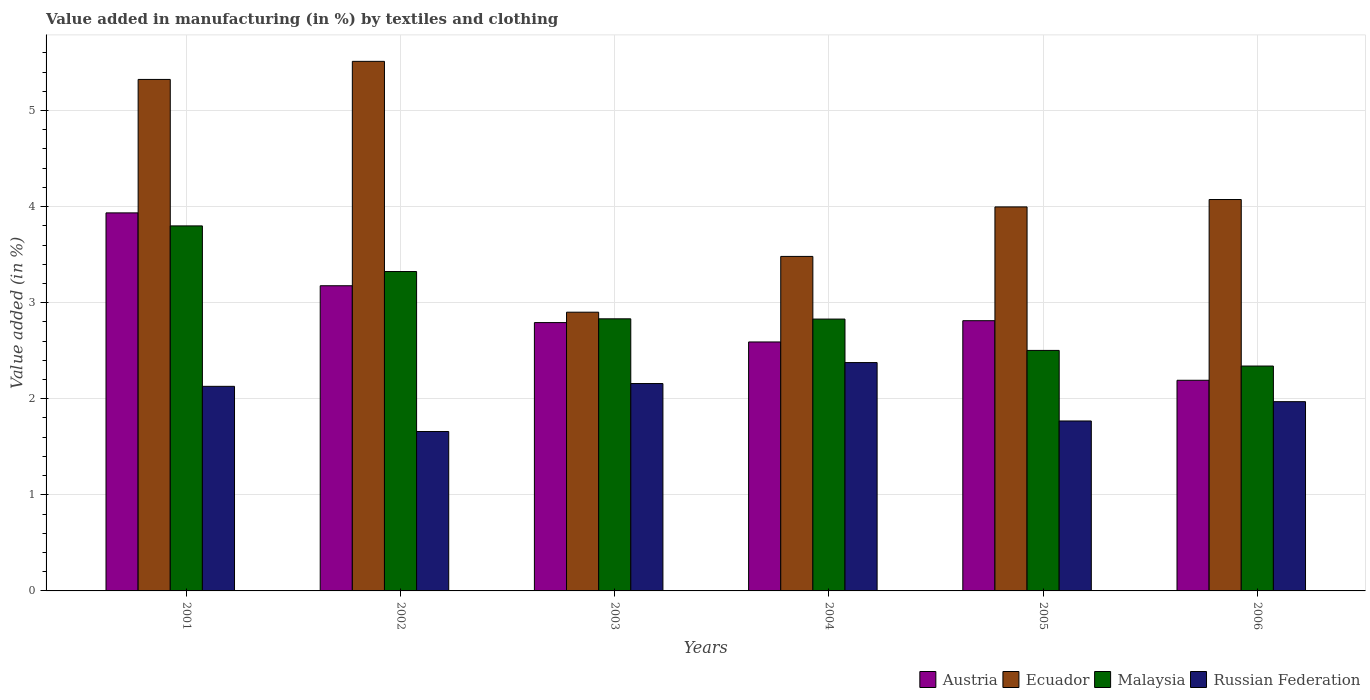How many groups of bars are there?
Make the answer very short. 6. Are the number of bars on each tick of the X-axis equal?
Give a very brief answer. Yes. What is the label of the 5th group of bars from the left?
Provide a short and direct response. 2005. What is the percentage of value added in manufacturing by textiles and clothing in Ecuador in 2004?
Give a very brief answer. 3.48. Across all years, what is the maximum percentage of value added in manufacturing by textiles and clothing in Ecuador?
Offer a very short reply. 5.51. Across all years, what is the minimum percentage of value added in manufacturing by textiles and clothing in Austria?
Provide a succinct answer. 2.19. In which year was the percentage of value added in manufacturing by textiles and clothing in Ecuador maximum?
Provide a short and direct response. 2002. In which year was the percentage of value added in manufacturing by textiles and clothing in Ecuador minimum?
Your answer should be compact. 2003. What is the total percentage of value added in manufacturing by textiles and clothing in Russian Federation in the graph?
Offer a very short reply. 12.06. What is the difference between the percentage of value added in manufacturing by textiles and clothing in Russian Federation in 2001 and that in 2006?
Your answer should be compact. 0.16. What is the difference between the percentage of value added in manufacturing by textiles and clothing in Austria in 2001 and the percentage of value added in manufacturing by textiles and clothing in Russian Federation in 2002?
Ensure brevity in your answer.  2.28. What is the average percentage of value added in manufacturing by textiles and clothing in Russian Federation per year?
Your answer should be very brief. 2.01. In the year 2005, what is the difference between the percentage of value added in manufacturing by textiles and clothing in Malaysia and percentage of value added in manufacturing by textiles and clothing in Ecuador?
Offer a very short reply. -1.49. In how many years, is the percentage of value added in manufacturing by textiles and clothing in Malaysia greater than 4 %?
Give a very brief answer. 0. What is the ratio of the percentage of value added in manufacturing by textiles and clothing in Ecuador in 2002 to that in 2004?
Offer a very short reply. 1.58. Is the percentage of value added in manufacturing by textiles and clothing in Russian Federation in 2003 less than that in 2004?
Give a very brief answer. Yes. Is the difference between the percentage of value added in manufacturing by textiles and clothing in Malaysia in 2002 and 2003 greater than the difference between the percentage of value added in manufacturing by textiles and clothing in Ecuador in 2002 and 2003?
Make the answer very short. No. What is the difference between the highest and the second highest percentage of value added in manufacturing by textiles and clothing in Russian Federation?
Offer a terse response. 0.22. What is the difference between the highest and the lowest percentage of value added in manufacturing by textiles and clothing in Ecuador?
Offer a terse response. 2.61. Is the sum of the percentage of value added in manufacturing by textiles and clothing in Russian Federation in 2001 and 2006 greater than the maximum percentage of value added in manufacturing by textiles and clothing in Austria across all years?
Give a very brief answer. Yes. What does the 4th bar from the left in 2003 represents?
Ensure brevity in your answer.  Russian Federation. What does the 2nd bar from the right in 2002 represents?
Give a very brief answer. Malaysia. Are all the bars in the graph horizontal?
Ensure brevity in your answer.  No. What is the difference between two consecutive major ticks on the Y-axis?
Make the answer very short. 1. Does the graph contain any zero values?
Provide a succinct answer. No. Where does the legend appear in the graph?
Make the answer very short. Bottom right. How many legend labels are there?
Offer a very short reply. 4. How are the legend labels stacked?
Your answer should be very brief. Horizontal. What is the title of the graph?
Your answer should be very brief. Value added in manufacturing (in %) by textiles and clothing. Does "American Samoa" appear as one of the legend labels in the graph?
Keep it short and to the point. No. What is the label or title of the Y-axis?
Your answer should be very brief. Value added (in %). What is the Value added (in %) of Austria in 2001?
Offer a very short reply. 3.93. What is the Value added (in %) of Ecuador in 2001?
Your answer should be compact. 5.32. What is the Value added (in %) of Malaysia in 2001?
Give a very brief answer. 3.8. What is the Value added (in %) of Russian Federation in 2001?
Your response must be concise. 2.13. What is the Value added (in %) in Austria in 2002?
Keep it short and to the point. 3.18. What is the Value added (in %) of Ecuador in 2002?
Ensure brevity in your answer.  5.51. What is the Value added (in %) in Malaysia in 2002?
Your answer should be very brief. 3.32. What is the Value added (in %) in Russian Federation in 2002?
Keep it short and to the point. 1.66. What is the Value added (in %) of Austria in 2003?
Your answer should be very brief. 2.79. What is the Value added (in %) of Ecuador in 2003?
Your response must be concise. 2.9. What is the Value added (in %) of Malaysia in 2003?
Provide a succinct answer. 2.83. What is the Value added (in %) of Russian Federation in 2003?
Your response must be concise. 2.16. What is the Value added (in %) in Austria in 2004?
Provide a succinct answer. 2.59. What is the Value added (in %) of Ecuador in 2004?
Offer a very short reply. 3.48. What is the Value added (in %) in Malaysia in 2004?
Give a very brief answer. 2.83. What is the Value added (in %) in Russian Federation in 2004?
Your response must be concise. 2.38. What is the Value added (in %) in Austria in 2005?
Offer a terse response. 2.81. What is the Value added (in %) in Ecuador in 2005?
Offer a terse response. 4. What is the Value added (in %) of Malaysia in 2005?
Your response must be concise. 2.5. What is the Value added (in %) in Russian Federation in 2005?
Your response must be concise. 1.77. What is the Value added (in %) of Austria in 2006?
Ensure brevity in your answer.  2.19. What is the Value added (in %) of Ecuador in 2006?
Your answer should be very brief. 4.07. What is the Value added (in %) of Malaysia in 2006?
Make the answer very short. 2.34. What is the Value added (in %) of Russian Federation in 2006?
Your answer should be very brief. 1.97. Across all years, what is the maximum Value added (in %) of Austria?
Provide a short and direct response. 3.93. Across all years, what is the maximum Value added (in %) of Ecuador?
Offer a terse response. 5.51. Across all years, what is the maximum Value added (in %) in Malaysia?
Your answer should be very brief. 3.8. Across all years, what is the maximum Value added (in %) in Russian Federation?
Your answer should be very brief. 2.38. Across all years, what is the minimum Value added (in %) in Austria?
Provide a succinct answer. 2.19. Across all years, what is the minimum Value added (in %) of Ecuador?
Your answer should be very brief. 2.9. Across all years, what is the minimum Value added (in %) of Malaysia?
Your answer should be compact. 2.34. Across all years, what is the minimum Value added (in %) in Russian Federation?
Provide a short and direct response. 1.66. What is the total Value added (in %) in Austria in the graph?
Ensure brevity in your answer.  17.5. What is the total Value added (in %) in Ecuador in the graph?
Ensure brevity in your answer.  25.29. What is the total Value added (in %) of Malaysia in the graph?
Your response must be concise. 17.63. What is the total Value added (in %) of Russian Federation in the graph?
Provide a short and direct response. 12.06. What is the difference between the Value added (in %) in Austria in 2001 and that in 2002?
Your response must be concise. 0.76. What is the difference between the Value added (in %) of Ecuador in 2001 and that in 2002?
Provide a short and direct response. -0.19. What is the difference between the Value added (in %) in Malaysia in 2001 and that in 2002?
Provide a short and direct response. 0.47. What is the difference between the Value added (in %) in Russian Federation in 2001 and that in 2002?
Give a very brief answer. 0.47. What is the difference between the Value added (in %) of Austria in 2001 and that in 2003?
Offer a terse response. 1.14. What is the difference between the Value added (in %) in Ecuador in 2001 and that in 2003?
Your answer should be compact. 2.42. What is the difference between the Value added (in %) in Malaysia in 2001 and that in 2003?
Make the answer very short. 0.97. What is the difference between the Value added (in %) of Russian Federation in 2001 and that in 2003?
Provide a short and direct response. -0.03. What is the difference between the Value added (in %) of Austria in 2001 and that in 2004?
Your answer should be very brief. 1.34. What is the difference between the Value added (in %) in Ecuador in 2001 and that in 2004?
Keep it short and to the point. 1.84. What is the difference between the Value added (in %) in Malaysia in 2001 and that in 2004?
Keep it short and to the point. 0.97. What is the difference between the Value added (in %) in Russian Federation in 2001 and that in 2004?
Offer a terse response. -0.25. What is the difference between the Value added (in %) in Austria in 2001 and that in 2005?
Ensure brevity in your answer.  1.12. What is the difference between the Value added (in %) of Ecuador in 2001 and that in 2005?
Provide a short and direct response. 1.33. What is the difference between the Value added (in %) in Malaysia in 2001 and that in 2005?
Your answer should be compact. 1.3. What is the difference between the Value added (in %) of Russian Federation in 2001 and that in 2005?
Give a very brief answer. 0.36. What is the difference between the Value added (in %) of Austria in 2001 and that in 2006?
Your answer should be very brief. 1.74. What is the difference between the Value added (in %) of Ecuador in 2001 and that in 2006?
Offer a terse response. 1.25. What is the difference between the Value added (in %) of Malaysia in 2001 and that in 2006?
Ensure brevity in your answer.  1.46. What is the difference between the Value added (in %) in Russian Federation in 2001 and that in 2006?
Make the answer very short. 0.16. What is the difference between the Value added (in %) of Austria in 2002 and that in 2003?
Make the answer very short. 0.38. What is the difference between the Value added (in %) of Ecuador in 2002 and that in 2003?
Provide a short and direct response. 2.61. What is the difference between the Value added (in %) of Malaysia in 2002 and that in 2003?
Your response must be concise. 0.49. What is the difference between the Value added (in %) of Russian Federation in 2002 and that in 2003?
Your answer should be very brief. -0.5. What is the difference between the Value added (in %) of Austria in 2002 and that in 2004?
Offer a very short reply. 0.59. What is the difference between the Value added (in %) of Ecuador in 2002 and that in 2004?
Make the answer very short. 2.03. What is the difference between the Value added (in %) in Malaysia in 2002 and that in 2004?
Give a very brief answer. 0.49. What is the difference between the Value added (in %) in Russian Federation in 2002 and that in 2004?
Keep it short and to the point. -0.72. What is the difference between the Value added (in %) in Austria in 2002 and that in 2005?
Ensure brevity in your answer.  0.36. What is the difference between the Value added (in %) of Ecuador in 2002 and that in 2005?
Your answer should be compact. 1.51. What is the difference between the Value added (in %) in Malaysia in 2002 and that in 2005?
Make the answer very short. 0.82. What is the difference between the Value added (in %) in Russian Federation in 2002 and that in 2005?
Your answer should be compact. -0.11. What is the difference between the Value added (in %) in Austria in 2002 and that in 2006?
Offer a very short reply. 0.98. What is the difference between the Value added (in %) in Ecuador in 2002 and that in 2006?
Your answer should be very brief. 1.44. What is the difference between the Value added (in %) of Malaysia in 2002 and that in 2006?
Ensure brevity in your answer.  0.98. What is the difference between the Value added (in %) of Russian Federation in 2002 and that in 2006?
Offer a terse response. -0.31. What is the difference between the Value added (in %) of Austria in 2003 and that in 2004?
Offer a terse response. 0.2. What is the difference between the Value added (in %) in Ecuador in 2003 and that in 2004?
Your response must be concise. -0.58. What is the difference between the Value added (in %) in Malaysia in 2003 and that in 2004?
Offer a terse response. 0. What is the difference between the Value added (in %) in Russian Federation in 2003 and that in 2004?
Your response must be concise. -0.22. What is the difference between the Value added (in %) in Austria in 2003 and that in 2005?
Give a very brief answer. -0.02. What is the difference between the Value added (in %) in Ecuador in 2003 and that in 2005?
Your response must be concise. -1.1. What is the difference between the Value added (in %) in Malaysia in 2003 and that in 2005?
Your answer should be compact. 0.33. What is the difference between the Value added (in %) in Russian Federation in 2003 and that in 2005?
Your answer should be very brief. 0.39. What is the difference between the Value added (in %) of Austria in 2003 and that in 2006?
Offer a very short reply. 0.6. What is the difference between the Value added (in %) in Ecuador in 2003 and that in 2006?
Ensure brevity in your answer.  -1.17. What is the difference between the Value added (in %) in Malaysia in 2003 and that in 2006?
Provide a succinct answer. 0.49. What is the difference between the Value added (in %) in Russian Federation in 2003 and that in 2006?
Provide a short and direct response. 0.19. What is the difference between the Value added (in %) in Austria in 2004 and that in 2005?
Make the answer very short. -0.22. What is the difference between the Value added (in %) of Ecuador in 2004 and that in 2005?
Your answer should be compact. -0.52. What is the difference between the Value added (in %) of Malaysia in 2004 and that in 2005?
Your answer should be very brief. 0.33. What is the difference between the Value added (in %) of Russian Federation in 2004 and that in 2005?
Give a very brief answer. 0.61. What is the difference between the Value added (in %) in Austria in 2004 and that in 2006?
Make the answer very short. 0.4. What is the difference between the Value added (in %) of Ecuador in 2004 and that in 2006?
Offer a terse response. -0.59. What is the difference between the Value added (in %) in Malaysia in 2004 and that in 2006?
Keep it short and to the point. 0.49. What is the difference between the Value added (in %) of Russian Federation in 2004 and that in 2006?
Your response must be concise. 0.41. What is the difference between the Value added (in %) of Austria in 2005 and that in 2006?
Offer a terse response. 0.62. What is the difference between the Value added (in %) in Ecuador in 2005 and that in 2006?
Offer a very short reply. -0.08. What is the difference between the Value added (in %) of Malaysia in 2005 and that in 2006?
Keep it short and to the point. 0.16. What is the difference between the Value added (in %) in Russian Federation in 2005 and that in 2006?
Make the answer very short. -0.2. What is the difference between the Value added (in %) of Austria in 2001 and the Value added (in %) of Ecuador in 2002?
Provide a short and direct response. -1.58. What is the difference between the Value added (in %) of Austria in 2001 and the Value added (in %) of Malaysia in 2002?
Provide a succinct answer. 0.61. What is the difference between the Value added (in %) in Austria in 2001 and the Value added (in %) in Russian Federation in 2002?
Your response must be concise. 2.28. What is the difference between the Value added (in %) of Ecuador in 2001 and the Value added (in %) of Malaysia in 2002?
Provide a succinct answer. 2. What is the difference between the Value added (in %) in Ecuador in 2001 and the Value added (in %) in Russian Federation in 2002?
Provide a succinct answer. 3.66. What is the difference between the Value added (in %) of Malaysia in 2001 and the Value added (in %) of Russian Federation in 2002?
Offer a very short reply. 2.14. What is the difference between the Value added (in %) in Austria in 2001 and the Value added (in %) in Ecuador in 2003?
Provide a short and direct response. 1.03. What is the difference between the Value added (in %) of Austria in 2001 and the Value added (in %) of Malaysia in 2003?
Provide a succinct answer. 1.1. What is the difference between the Value added (in %) of Austria in 2001 and the Value added (in %) of Russian Federation in 2003?
Your answer should be very brief. 1.78. What is the difference between the Value added (in %) in Ecuador in 2001 and the Value added (in %) in Malaysia in 2003?
Your answer should be very brief. 2.49. What is the difference between the Value added (in %) of Ecuador in 2001 and the Value added (in %) of Russian Federation in 2003?
Make the answer very short. 3.17. What is the difference between the Value added (in %) of Malaysia in 2001 and the Value added (in %) of Russian Federation in 2003?
Keep it short and to the point. 1.64. What is the difference between the Value added (in %) of Austria in 2001 and the Value added (in %) of Ecuador in 2004?
Make the answer very short. 0.45. What is the difference between the Value added (in %) in Austria in 2001 and the Value added (in %) in Malaysia in 2004?
Give a very brief answer. 1.11. What is the difference between the Value added (in %) of Austria in 2001 and the Value added (in %) of Russian Federation in 2004?
Give a very brief answer. 1.56. What is the difference between the Value added (in %) in Ecuador in 2001 and the Value added (in %) in Malaysia in 2004?
Offer a very short reply. 2.49. What is the difference between the Value added (in %) of Ecuador in 2001 and the Value added (in %) of Russian Federation in 2004?
Offer a very short reply. 2.95. What is the difference between the Value added (in %) of Malaysia in 2001 and the Value added (in %) of Russian Federation in 2004?
Give a very brief answer. 1.42. What is the difference between the Value added (in %) in Austria in 2001 and the Value added (in %) in Ecuador in 2005?
Provide a succinct answer. -0.06. What is the difference between the Value added (in %) in Austria in 2001 and the Value added (in %) in Malaysia in 2005?
Your response must be concise. 1.43. What is the difference between the Value added (in %) in Austria in 2001 and the Value added (in %) in Russian Federation in 2005?
Give a very brief answer. 2.17. What is the difference between the Value added (in %) in Ecuador in 2001 and the Value added (in %) in Malaysia in 2005?
Offer a terse response. 2.82. What is the difference between the Value added (in %) of Ecuador in 2001 and the Value added (in %) of Russian Federation in 2005?
Offer a terse response. 3.55. What is the difference between the Value added (in %) of Malaysia in 2001 and the Value added (in %) of Russian Federation in 2005?
Make the answer very short. 2.03. What is the difference between the Value added (in %) of Austria in 2001 and the Value added (in %) of Ecuador in 2006?
Keep it short and to the point. -0.14. What is the difference between the Value added (in %) of Austria in 2001 and the Value added (in %) of Malaysia in 2006?
Offer a terse response. 1.59. What is the difference between the Value added (in %) in Austria in 2001 and the Value added (in %) in Russian Federation in 2006?
Offer a very short reply. 1.96. What is the difference between the Value added (in %) in Ecuador in 2001 and the Value added (in %) in Malaysia in 2006?
Provide a short and direct response. 2.98. What is the difference between the Value added (in %) of Ecuador in 2001 and the Value added (in %) of Russian Federation in 2006?
Your answer should be compact. 3.35. What is the difference between the Value added (in %) in Malaysia in 2001 and the Value added (in %) in Russian Federation in 2006?
Give a very brief answer. 1.83. What is the difference between the Value added (in %) in Austria in 2002 and the Value added (in %) in Ecuador in 2003?
Keep it short and to the point. 0.28. What is the difference between the Value added (in %) in Austria in 2002 and the Value added (in %) in Malaysia in 2003?
Make the answer very short. 0.34. What is the difference between the Value added (in %) in Austria in 2002 and the Value added (in %) in Russian Federation in 2003?
Your answer should be compact. 1.02. What is the difference between the Value added (in %) of Ecuador in 2002 and the Value added (in %) of Malaysia in 2003?
Offer a very short reply. 2.68. What is the difference between the Value added (in %) of Ecuador in 2002 and the Value added (in %) of Russian Federation in 2003?
Give a very brief answer. 3.35. What is the difference between the Value added (in %) of Malaysia in 2002 and the Value added (in %) of Russian Federation in 2003?
Your answer should be very brief. 1.17. What is the difference between the Value added (in %) in Austria in 2002 and the Value added (in %) in Ecuador in 2004?
Offer a terse response. -0.31. What is the difference between the Value added (in %) in Austria in 2002 and the Value added (in %) in Malaysia in 2004?
Make the answer very short. 0.35. What is the difference between the Value added (in %) in Austria in 2002 and the Value added (in %) in Russian Federation in 2004?
Provide a succinct answer. 0.8. What is the difference between the Value added (in %) of Ecuador in 2002 and the Value added (in %) of Malaysia in 2004?
Ensure brevity in your answer.  2.68. What is the difference between the Value added (in %) in Ecuador in 2002 and the Value added (in %) in Russian Federation in 2004?
Make the answer very short. 3.13. What is the difference between the Value added (in %) in Malaysia in 2002 and the Value added (in %) in Russian Federation in 2004?
Your response must be concise. 0.95. What is the difference between the Value added (in %) of Austria in 2002 and the Value added (in %) of Ecuador in 2005?
Offer a very short reply. -0.82. What is the difference between the Value added (in %) in Austria in 2002 and the Value added (in %) in Malaysia in 2005?
Your response must be concise. 0.67. What is the difference between the Value added (in %) of Austria in 2002 and the Value added (in %) of Russian Federation in 2005?
Offer a very short reply. 1.41. What is the difference between the Value added (in %) in Ecuador in 2002 and the Value added (in %) in Malaysia in 2005?
Provide a short and direct response. 3.01. What is the difference between the Value added (in %) of Ecuador in 2002 and the Value added (in %) of Russian Federation in 2005?
Make the answer very short. 3.74. What is the difference between the Value added (in %) in Malaysia in 2002 and the Value added (in %) in Russian Federation in 2005?
Give a very brief answer. 1.56. What is the difference between the Value added (in %) of Austria in 2002 and the Value added (in %) of Ecuador in 2006?
Your response must be concise. -0.9. What is the difference between the Value added (in %) in Austria in 2002 and the Value added (in %) in Malaysia in 2006?
Your answer should be very brief. 0.84. What is the difference between the Value added (in %) of Austria in 2002 and the Value added (in %) of Russian Federation in 2006?
Make the answer very short. 1.21. What is the difference between the Value added (in %) in Ecuador in 2002 and the Value added (in %) in Malaysia in 2006?
Provide a succinct answer. 3.17. What is the difference between the Value added (in %) of Ecuador in 2002 and the Value added (in %) of Russian Federation in 2006?
Make the answer very short. 3.54. What is the difference between the Value added (in %) of Malaysia in 2002 and the Value added (in %) of Russian Federation in 2006?
Ensure brevity in your answer.  1.35. What is the difference between the Value added (in %) in Austria in 2003 and the Value added (in %) in Ecuador in 2004?
Provide a short and direct response. -0.69. What is the difference between the Value added (in %) of Austria in 2003 and the Value added (in %) of Malaysia in 2004?
Offer a very short reply. -0.04. What is the difference between the Value added (in %) in Austria in 2003 and the Value added (in %) in Russian Federation in 2004?
Provide a short and direct response. 0.42. What is the difference between the Value added (in %) in Ecuador in 2003 and the Value added (in %) in Malaysia in 2004?
Provide a succinct answer. 0.07. What is the difference between the Value added (in %) in Ecuador in 2003 and the Value added (in %) in Russian Federation in 2004?
Provide a succinct answer. 0.52. What is the difference between the Value added (in %) of Malaysia in 2003 and the Value added (in %) of Russian Federation in 2004?
Your answer should be compact. 0.46. What is the difference between the Value added (in %) of Austria in 2003 and the Value added (in %) of Ecuador in 2005?
Ensure brevity in your answer.  -1.2. What is the difference between the Value added (in %) of Austria in 2003 and the Value added (in %) of Malaysia in 2005?
Keep it short and to the point. 0.29. What is the difference between the Value added (in %) of Austria in 2003 and the Value added (in %) of Russian Federation in 2005?
Provide a succinct answer. 1.02. What is the difference between the Value added (in %) of Ecuador in 2003 and the Value added (in %) of Malaysia in 2005?
Provide a succinct answer. 0.4. What is the difference between the Value added (in %) in Ecuador in 2003 and the Value added (in %) in Russian Federation in 2005?
Your answer should be compact. 1.13. What is the difference between the Value added (in %) in Malaysia in 2003 and the Value added (in %) in Russian Federation in 2005?
Your answer should be compact. 1.06. What is the difference between the Value added (in %) of Austria in 2003 and the Value added (in %) of Ecuador in 2006?
Offer a very short reply. -1.28. What is the difference between the Value added (in %) of Austria in 2003 and the Value added (in %) of Malaysia in 2006?
Give a very brief answer. 0.45. What is the difference between the Value added (in %) in Austria in 2003 and the Value added (in %) in Russian Federation in 2006?
Provide a short and direct response. 0.82. What is the difference between the Value added (in %) of Ecuador in 2003 and the Value added (in %) of Malaysia in 2006?
Provide a short and direct response. 0.56. What is the difference between the Value added (in %) of Ecuador in 2003 and the Value added (in %) of Russian Federation in 2006?
Your answer should be compact. 0.93. What is the difference between the Value added (in %) of Malaysia in 2003 and the Value added (in %) of Russian Federation in 2006?
Your answer should be compact. 0.86. What is the difference between the Value added (in %) in Austria in 2004 and the Value added (in %) in Ecuador in 2005?
Keep it short and to the point. -1.41. What is the difference between the Value added (in %) in Austria in 2004 and the Value added (in %) in Malaysia in 2005?
Give a very brief answer. 0.09. What is the difference between the Value added (in %) of Austria in 2004 and the Value added (in %) of Russian Federation in 2005?
Keep it short and to the point. 0.82. What is the difference between the Value added (in %) in Ecuador in 2004 and the Value added (in %) in Malaysia in 2005?
Ensure brevity in your answer.  0.98. What is the difference between the Value added (in %) in Ecuador in 2004 and the Value added (in %) in Russian Federation in 2005?
Offer a very short reply. 1.71. What is the difference between the Value added (in %) in Malaysia in 2004 and the Value added (in %) in Russian Federation in 2005?
Ensure brevity in your answer.  1.06. What is the difference between the Value added (in %) in Austria in 2004 and the Value added (in %) in Ecuador in 2006?
Your response must be concise. -1.48. What is the difference between the Value added (in %) in Austria in 2004 and the Value added (in %) in Malaysia in 2006?
Keep it short and to the point. 0.25. What is the difference between the Value added (in %) in Austria in 2004 and the Value added (in %) in Russian Federation in 2006?
Keep it short and to the point. 0.62. What is the difference between the Value added (in %) in Ecuador in 2004 and the Value added (in %) in Malaysia in 2006?
Keep it short and to the point. 1.14. What is the difference between the Value added (in %) in Ecuador in 2004 and the Value added (in %) in Russian Federation in 2006?
Offer a terse response. 1.51. What is the difference between the Value added (in %) in Malaysia in 2004 and the Value added (in %) in Russian Federation in 2006?
Give a very brief answer. 0.86. What is the difference between the Value added (in %) of Austria in 2005 and the Value added (in %) of Ecuador in 2006?
Your answer should be very brief. -1.26. What is the difference between the Value added (in %) in Austria in 2005 and the Value added (in %) in Malaysia in 2006?
Offer a terse response. 0.47. What is the difference between the Value added (in %) in Austria in 2005 and the Value added (in %) in Russian Federation in 2006?
Your response must be concise. 0.84. What is the difference between the Value added (in %) in Ecuador in 2005 and the Value added (in %) in Malaysia in 2006?
Offer a very short reply. 1.66. What is the difference between the Value added (in %) in Ecuador in 2005 and the Value added (in %) in Russian Federation in 2006?
Your answer should be compact. 2.03. What is the difference between the Value added (in %) in Malaysia in 2005 and the Value added (in %) in Russian Federation in 2006?
Make the answer very short. 0.53. What is the average Value added (in %) in Austria per year?
Your answer should be compact. 2.92. What is the average Value added (in %) of Ecuador per year?
Your answer should be compact. 4.21. What is the average Value added (in %) of Malaysia per year?
Give a very brief answer. 2.94. What is the average Value added (in %) of Russian Federation per year?
Your response must be concise. 2.01. In the year 2001, what is the difference between the Value added (in %) of Austria and Value added (in %) of Ecuador?
Offer a terse response. -1.39. In the year 2001, what is the difference between the Value added (in %) of Austria and Value added (in %) of Malaysia?
Ensure brevity in your answer.  0.14. In the year 2001, what is the difference between the Value added (in %) in Austria and Value added (in %) in Russian Federation?
Ensure brevity in your answer.  1.81. In the year 2001, what is the difference between the Value added (in %) in Ecuador and Value added (in %) in Malaysia?
Make the answer very short. 1.52. In the year 2001, what is the difference between the Value added (in %) in Ecuador and Value added (in %) in Russian Federation?
Make the answer very short. 3.19. In the year 2001, what is the difference between the Value added (in %) in Malaysia and Value added (in %) in Russian Federation?
Provide a short and direct response. 1.67. In the year 2002, what is the difference between the Value added (in %) of Austria and Value added (in %) of Ecuador?
Give a very brief answer. -2.34. In the year 2002, what is the difference between the Value added (in %) in Austria and Value added (in %) in Malaysia?
Keep it short and to the point. -0.15. In the year 2002, what is the difference between the Value added (in %) in Austria and Value added (in %) in Russian Federation?
Make the answer very short. 1.52. In the year 2002, what is the difference between the Value added (in %) in Ecuador and Value added (in %) in Malaysia?
Provide a short and direct response. 2.19. In the year 2002, what is the difference between the Value added (in %) of Ecuador and Value added (in %) of Russian Federation?
Keep it short and to the point. 3.85. In the year 2002, what is the difference between the Value added (in %) in Malaysia and Value added (in %) in Russian Federation?
Ensure brevity in your answer.  1.66. In the year 2003, what is the difference between the Value added (in %) in Austria and Value added (in %) in Ecuador?
Offer a terse response. -0.11. In the year 2003, what is the difference between the Value added (in %) in Austria and Value added (in %) in Malaysia?
Your response must be concise. -0.04. In the year 2003, what is the difference between the Value added (in %) of Austria and Value added (in %) of Russian Federation?
Provide a short and direct response. 0.63. In the year 2003, what is the difference between the Value added (in %) in Ecuador and Value added (in %) in Malaysia?
Your response must be concise. 0.07. In the year 2003, what is the difference between the Value added (in %) in Ecuador and Value added (in %) in Russian Federation?
Make the answer very short. 0.74. In the year 2003, what is the difference between the Value added (in %) of Malaysia and Value added (in %) of Russian Federation?
Give a very brief answer. 0.67. In the year 2004, what is the difference between the Value added (in %) in Austria and Value added (in %) in Ecuador?
Make the answer very short. -0.89. In the year 2004, what is the difference between the Value added (in %) in Austria and Value added (in %) in Malaysia?
Provide a succinct answer. -0.24. In the year 2004, what is the difference between the Value added (in %) of Austria and Value added (in %) of Russian Federation?
Keep it short and to the point. 0.21. In the year 2004, what is the difference between the Value added (in %) of Ecuador and Value added (in %) of Malaysia?
Offer a very short reply. 0.65. In the year 2004, what is the difference between the Value added (in %) of Ecuador and Value added (in %) of Russian Federation?
Provide a succinct answer. 1.1. In the year 2004, what is the difference between the Value added (in %) in Malaysia and Value added (in %) in Russian Federation?
Your response must be concise. 0.45. In the year 2005, what is the difference between the Value added (in %) in Austria and Value added (in %) in Ecuador?
Your answer should be very brief. -1.18. In the year 2005, what is the difference between the Value added (in %) in Austria and Value added (in %) in Malaysia?
Keep it short and to the point. 0.31. In the year 2005, what is the difference between the Value added (in %) of Austria and Value added (in %) of Russian Federation?
Ensure brevity in your answer.  1.04. In the year 2005, what is the difference between the Value added (in %) of Ecuador and Value added (in %) of Malaysia?
Your answer should be compact. 1.49. In the year 2005, what is the difference between the Value added (in %) of Ecuador and Value added (in %) of Russian Federation?
Offer a terse response. 2.23. In the year 2005, what is the difference between the Value added (in %) of Malaysia and Value added (in %) of Russian Federation?
Make the answer very short. 0.73. In the year 2006, what is the difference between the Value added (in %) of Austria and Value added (in %) of Ecuador?
Provide a succinct answer. -1.88. In the year 2006, what is the difference between the Value added (in %) in Austria and Value added (in %) in Malaysia?
Your response must be concise. -0.15. In the year 2006, what is the difference between the Value added (in %) in Austria and Value added (in %) in Russian Federation?
Offer a very short reply. 0.22. In the year 2006, what is the difference between the Value added (in %) in Ecuador and Value added (in %) in Malaysia?
Offer a very short reply. 1.73. In the year 2006, what is the difference between the Value added (in %) of Ecuador and Value added (in %) of Russian Federation?
Give a very brief answer. 2.1. In the year 2006, what is the difference between the Value added (in %) in Malaysia and Value added (in %) in Russian Federation?
Offer a terse response. 0.37. What is the ratio of the Value added (in %) in Austria in 2001 to that in 2002?
Offer a very short reply. 1.24. What is the ratio of the Value added (in %) of Ecuador in 2001 to that in 2002?
Your response must be concise. 0.97. What is the ratio of the Value added (in %) of Russian Federation in 2001 to that in 2002?
Offer a terse response. 1.28. What is the ratio of the Value added (in %) in Austria in 2001 to that in 2003?
Provide a succinct answer. 1.41. What is the ratio of the Value added (in %) of Ecuador in 2001 to that in 2003?
Provide a succinct answer. 1.84. What is the ratio of the Value added (in %) of Malaysia in 2001 to that in 2003?
Provide a succinct answer. 1.34. What is the ratio of the Value added (in %) of Russian Federation in 2001 to that in 2003?
Make the answer very short. 0.99. What is the ratio of the Value added (in %) of Austria in 2001 to that in 2004?
Ensure brevity in your answer.  1.52. What is the ratio of the Value added (in %) of Ecuador in 2001 to that in 2004?
Make the answer very short. 1.53. What is the ratio of the Value added (in %) in Malaysia in 2001 to that in 2004?
Provide a short and direct response. 1.34. What is the ratio of the Value added (in %) of Russian Federation in 2001 to that in 2004?
Ensure brevity in your answer.  0.9. What is the ratio of the Value added (in %) in Austria in 2001 to that in 2005?
Offer a terse response. 1.4. What is the ratio of the Value added (in %) of Ecuador in 2001 to that in 2005?
Your answer should be compact. 1.33. What is the ratio of the Value added (in %) of Malaysia in 2001 to that in 2005?
Keep it short and to the point. 1.52. What is the ratio of the Value added (in %) of Russian Federation in 2001 to that in 2005?
Your answer should be very brief. 1.2. What is the ratio of the Value added (in %) in Austria in 2001 to that in 2006?
Your answer should be very brief. 1.79. What is the ratio of the Value added (in %) of Ecuador in 2001 to that in 2006?
Ensure brevity in your answer.  1.31. What is the ratio of the Value added (in %) in Malaysia in 2001 to that in 2006?
Offer a very short reply. 1.62. What is the ratio of the Value added (in %) of Russian Federation in 2001 to that in 2006?
Your answer should be compact. 1.08. What is the ratio of the Value added (in %) of Austria in 2002 to that in 2003?
Offer a terse response. 1.14. What is the ratio of the Value added (in %) of Malaysia in 2002 to that in 2003?
Your response must be concise. 1.17. What is the ratio of the Value added (in %) of Russian Federation in 2002 to that in 2003?
Provide a short and direct response. 0.77. What is the ratio of the Value added (in %) in Austria in 2002 to that in 2004?
Your answer should be compact. 1.23. What is the ratio of the Value added (in %) in Ecuador in 2002 to that in 2004?
Your answer should be very brief. 1.58. What is the ratio of the Value added (in %) of Malaysia in 2002 to that in 2004?
Give a very brief answer. 1.17. What is the ratio of the Value added (in %) of Russian Federation in 2002 to that in 2004?
Offer a very short reply. 0.7. What is the ratio of the Value added (in %) of Austria in 2002 to that in 2005?
Your answer should be compact. 1.13. What is the ratio of the Value added (in %) in Ecuador in 2002 to that in 2005?
Your answer should be compact. 1.38. What is the ratio of the Value added (in %) in Malaysia in 2002 to that in 2005?
Provide a succinct answer. 1.33. What is the ratio of the Value added (in %) in Russian Federation in 2002 to that in 2005?
Your answer should be very brief. 0.94. What is the ratio of the Value added (in %) of Austria in 2002 to that in 2006?
Make the answer very short. 1.45. What is the ratio of the Value added (in %) in Ecuador in 2002 to that in 2006?
Provide a short and direct response. 1.35. What is the ratio of the Value added (in %) of Malaysia in 2002 to that in 2006?
Your answer should be compact. 1.42. What is the ratio of the Value added (in %) of Russian Federation in 2002 to that in 2006?
Provide a succinct answer. 0.84. What is the ratio of the Value added (in %) in Austria in 2003 to that in 2004?
Provide a short and direct response. 1.08. What is the ratio of the Value added (in %) in Ecuador in 2003 to that in 2004?
Provide a succinct answer. 0.83. What is the ratio of the Value added (in %) in Russian Federation in 2003 to that in 2004?
Offer a terse response. 0.91. What is the ratio of the Value added (in %) in Austria in 2003 to that in 2005?
Ensure brevity in your answer.  0.99. What is the ratio of the Value added (in %) of Ecuador in 2003 to that in 2005?
Offer a very short reply. 0.73. What is the ratio of the Value added (in %) of Malaysia in 2003 to that in 2005?
Provide a succinct answer. 1.13. What is the ratio of the Value added (in %) of Russian Federation in 2003 to that in 2005?
Make the answer very short. 1.22. What is the ratio of the Value added (in %) in Austria in 2003 to that in 2006?
Your answer should be compact. 1.27. What is the ratio of the Value added (in %) in Ecuador in 2003 to that in 2006?
Give a very brief answer. 0.71. What is the ratio of the Value added (in %) of Malaysia in 2003 to that in 2006?
Provide a short and direct response. 1.21. What is the ratio of the Value added (in %) in Russian Federation in 2003 to that in 2006?
Ensure brevity in your answer.  1.1. What is the ratio of the Value added (in %) in Austria in 2004 to that in 2005?
Your answer should be compact. 0.92. What is the ratio of the Value added (in %) of Ecuador in 2004 to that in 2005?
Provide a succinct answer. 0.87. What is the ratio of the Value added (in %) in Malaysia in 2004 to that in 2005?
Keep it short and to the point. 1.13. What is the ratio of the Value added (in %) of Russian Federation in 2004 to that in 2005?
Offer a terse response. 1.34. What is the ratio of the Value added (in %) in Austria in 2004 to that in 2006?
Your response must be concise. 1.18. What is the ratio of the Value added (in %) of Ecuador in 2004 to that in 2006?
Keep it short and to the point. 0.85. What is the ratio of the Value added (in %) of Malaysia in 2004 to that in 2006?
Offer a very short reply. 1.21. What is the ratio of the Value added (in %) of Russian Federation in 2004 to that in 2006?
Your answer should be compact. 1.21. What is the ratio of the Value added (in %) in Austria in 2005 to that in 2006?
Your response must be concise. 1.28. What is the ratio of the Value added (in %) in Ecuador in 2005 to that in 2006?
Your response must be concise. 0.98. What is the ratio of the Value added (in %) of Malaysia in 2005 to that in 2006?
Give a very brief answer. 1.07. What is the ratio of the Value added (in %) in Russian Federation in 2005 to that in 2006?
Your answer should be very brief. 0.9. What is the difference between the highest and the second highest Value added (in %) in Austria?
Your response must be concise. 0.76. What is the difference between the highest and the second highest Value added (in %) in Ecuador?
Offer a very short reply. 0.19. What is the difference between the highest and the second highest Value added (in %) in Malaysia?
Give a very brief answer. 0.47. What is the difference between the highest and the second highest Value added (in %) in Russian Federation?
Keep it short and to the point. 0.22. What is the difference between the highest and the lowest Value added (in %) in Austria?
Provide a short and direct response. 1.74. What is the difference between the highest and the lowest Value added (in %) in Ecuador?
Keep it short and to the point. 2.61. What is the difference between the highest and the lowest Value added (in %) in Malaysia?
Provide a succinct answer. 1.46. What is the difference between the highest and the lowest Value added (in %) of Russian Federation?
Provide a succinct answer. 0.72. 